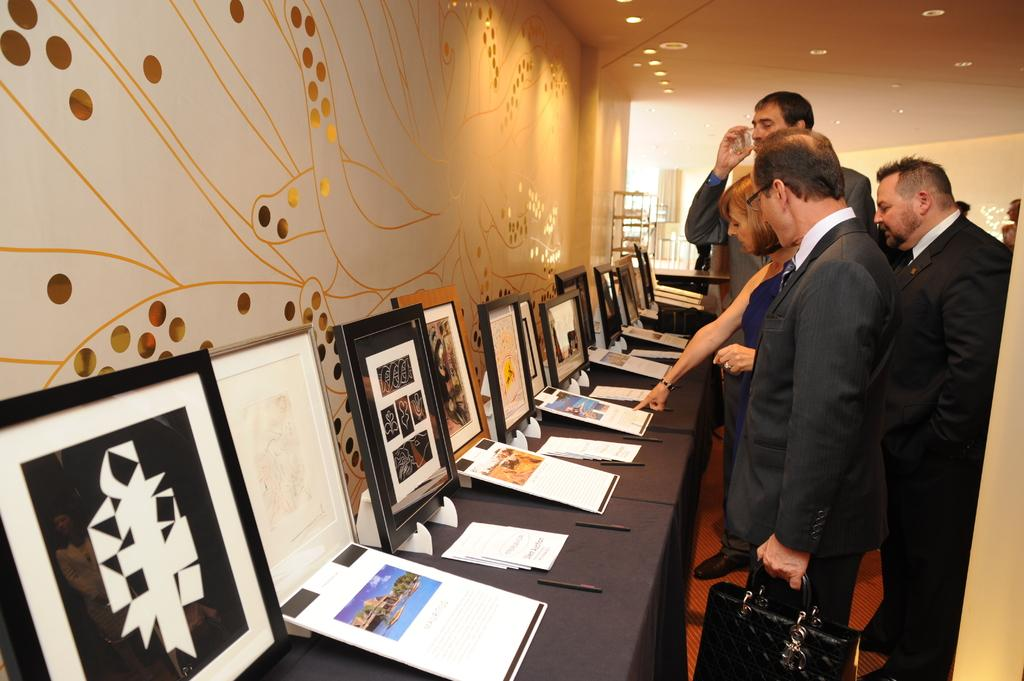What are the people in the image doing? The persons are standing in front of a table. What is the man holding in the image? The man is holding a bag. Can you describe the man's attire? The man is wearing a suit. What items can be seen on the table? There are photos and cards on the table. Are there any patches visible on the table in the image? There is no mention of patches in the image, so we cannot determine if any are present. Can you see any horses in the image? There are no horses visible in the image. 